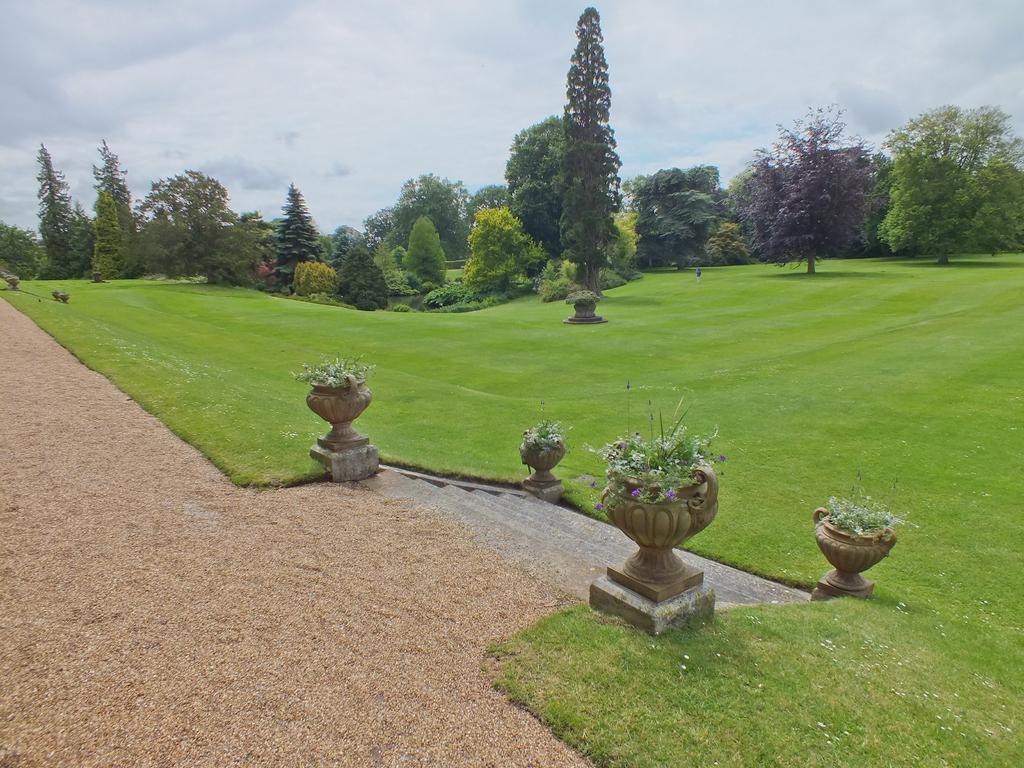Can you describe this image briefly? In this image we can see sand, stairs, potted plants, grass and in the background there are trees and sky. 